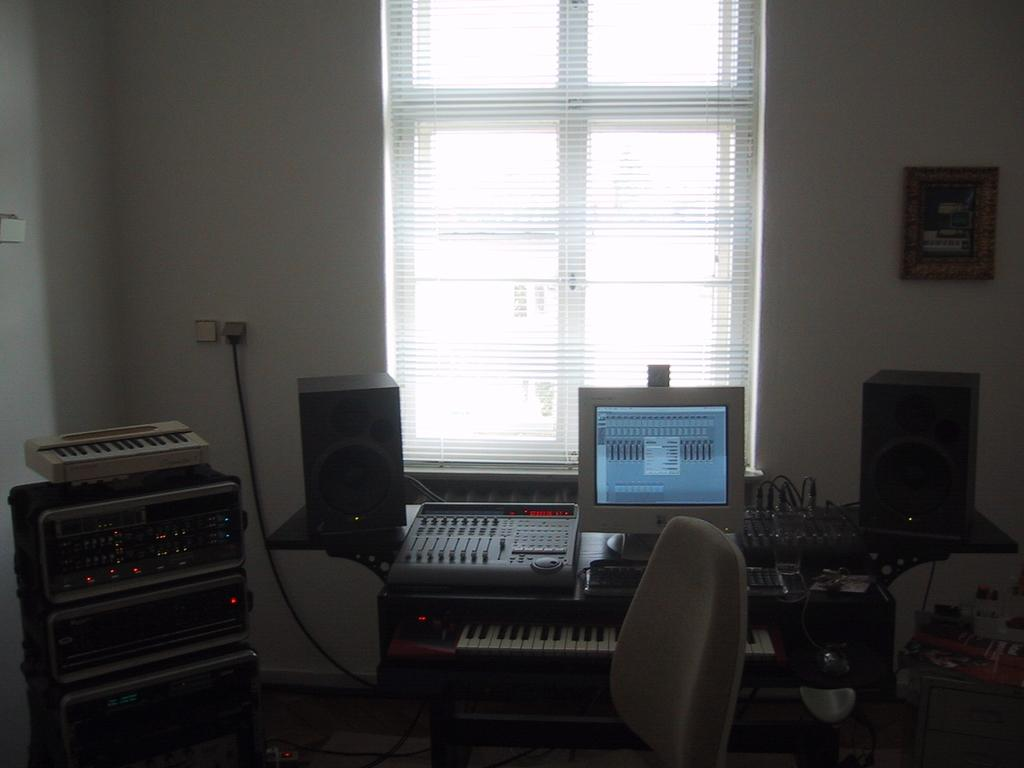What type of window is visible in the image? There is a window with curtains in the image. What objects are in front of the window? There are speakers, a monitor, a piano, and a machine in front of the window. What type of wall is visible in the image? There is a wall in the image. What type of frame is present in the image? There is a frame in the image. What type of furniture is present in the image? There is a chair in the image, and a frame in the image. Can you see a club in the image? There is no club present in the image. Is there an airplane visible in the image? There is no airplane present in the image. Is there a ghost in the image? There is no ghost present in the image. 